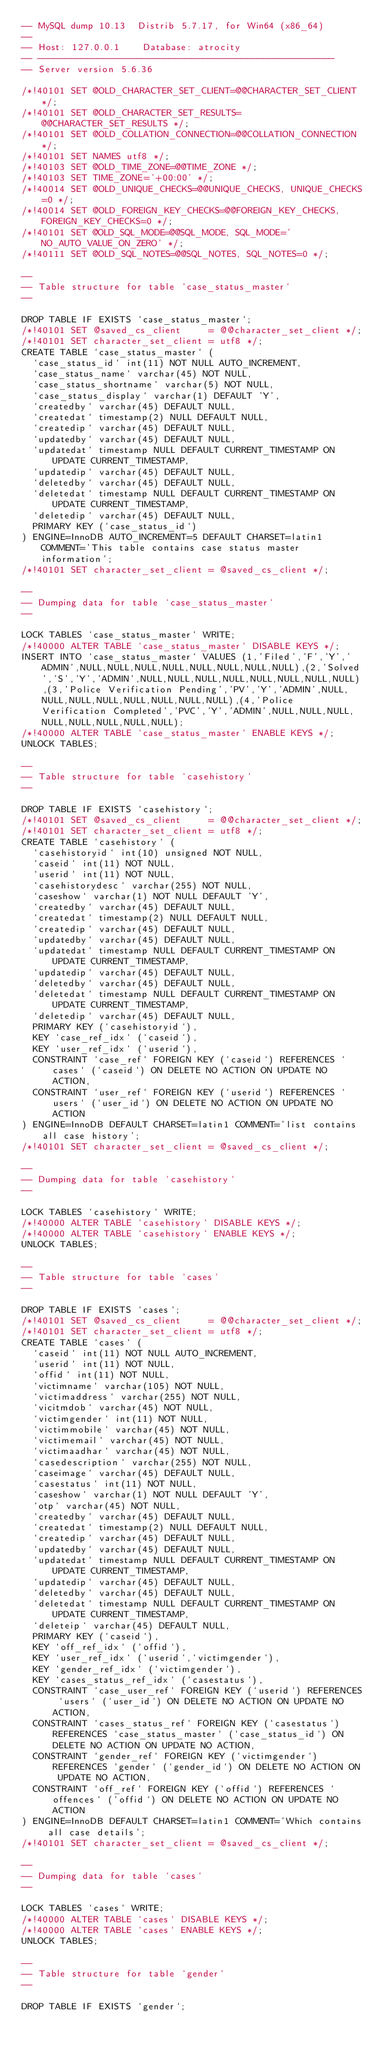Convert code to text. <code><loc_0><loc_0><loc_500><loc_500><_SQL_>-- MySQL dump 10.13  Distrib 5.7.17, for Win64 (x86_64)
--
-- Host: 127.0.0.1    Database: atrocity
-- ------------------------------------------------------
-- Server version	5.6.36

/*!40101 SET @OLD_CHARACTER_SET_CLIENT=@@CHARACTER_SET_CLIENT */;
/*!40101 SET @OLD_CHARACTER_SET_RESULTS=@@CHARACTER_SET_RESULTS */;
/*!40101 SET @OLD_COLLATION_CONNECTION=@@COLLATION_CONNECTION */;
/*!40101 SET NAMES utf8 */;
/*!40103 SET @OLD_TIME_ZONE=@@TIME_ZONE */;
/*!40103 SET TIME_ZONE='+00:00' */;
/*!40014 SET @OLD_UNIQUE_CHECKS=@@UNIQUE_CHECKS, UNIQUE_CHECKS=0 */;
/*!40014 SET @OLD_FOREIGN_KEY_CHECKS=@@FOREIGN_KEY_CHECKS, FOREIGN_KEY_CHECKS=0 */;
/*!40101 SET @OLD_SQL_MODE=@@SQL_MODE, SQL_MODE='NO_AUTO_VALUE_ON_ZERO' */;
/*!40111 SET @OLD_SQL_NOTES=@@SQL_NOTES, SQL_NOTES=0 */;

--
-- Table structure for table `case_status_master`
--

DROP TABLE IF EXISTS `case_status_master`;
/*!40101 SET @saved_cs_client     = @@character_set_client */;
/*!40101 SET character_set_client = utf8 */;
CREATE TABLE `case_status_master` (
  `case_status_id` int(11) NOT NULL AUTO_INCREMENT,
  `case_status_name` varchar(45) NOT NULL,
  `case_status_shortname` varchar(5) NOT NULL,
  `case_status_display` varchar(1) DEFAULT 'Y',
  `createdby` varchar(45) DEFAULT NULL,
  `createdat` timestamp(2) NULL DEFAULT NULL,
  `createdip` varchar(45) DEFAULT NULL,
  `updatedby` varchar(45) DEFAULT NULL,
  `updatedat` timestamp NULL DEFAULT CURRENT_TIMESTAMP ON UPDATE CURRENT_TIMESTAMP,
  `updatedip` varchar(45) DEFAULT NULL,
  `deletedby` varchar(45) DEFAULT NULL,
  `deletedat` timestamp NULL DEFAULT CURRENT_TIMESTAMP ON UPDATE CURRENT_TIMESTAMP,
  `deletedip` varchar(45) DEFAULT NULL,
  PRIMARY KEY (`case_status_id`)
) ENGINE=InnoDB AUTO_INCREMENT=5 DEFAULT CHARSET=latin1 COMMENT='This table contains case status master information';
/*!40101 SET character_set_client = @saved_cs_client */;

--
-- Dumping data for table `case_status_master`
--

LOCK TABLES `case_status_master` WRITE;
/*!40000 ALTER TABLE `case_status_master` DISABLE KEYS */;
INSERT INTO `case_status_master` VALUES (1,'Filed','F','Y','ADMIN',NULL,NULL,NULL,NULL,NULL,NULL,NULL,NULL),(2,'Solved','S','Y','ADMIN',NULL,NULL,NULL,NULL,NULL,NULL,NULL,NULL),(3,'Police Verification Pending','PV','Y','ADMIN',NULL,NULL,NULL,NULL,NULL,NULL,NULL,NULL),(4,'Police Verification Completed','PVC','Y','ADMIN',NULL,NULL,NULL,NULL,NULL,NULL,NULL,NULL);
/*!40000 ALTER TABLE `case_status_master` ENABLE KEYS */;
UNLOCK TABLES;

--
-- Table structure for table `casehistory`
--

DROP TABLE IF EXISTS `casehistory`;
/*!40101 SET @saved_cs_client     = @@character_set_client */;
/*!40101 SET character_set_client = utf8 */;
CREATE TABLE `casehistory` (
  `casehistoryid` int(10) unsigned NOT NULL,
  `caseid` int(11) NOT NULL,
  `userid` int(11) NOT NULL,
  `casehistorydesc` varchar(255) NOT NULL,
  `caseshow` varchar(1) NOT NULL DEFAULT 'Y',
  `createdby` varchar(45) DEFAULT NULL,
  `createdat` timestamp(2) NULL DEFAULT NULL,
  `createdip` varchar(45) DEFAULT NULL,
  `updatedby` varchar(45) DEFAULT NULL,
  `updatedat` timestamp NULL DEFAULT CURRENT_TIMESTAMP ON UPDATE CURRENT_TIMESTAMP,
  `updatedip` varchar(45) DEFAULT NULL,
  `deletedby` varchar(45) DEFAULT NULL,
  `deletedat` timestamp NULL DEFAULT CURRENT_TIMESTAMP ON UPDATE CURRENT_TIMESTAMP,
  `deletedip` varchar(45) DEFAULT NULL,
  PRIMARY KEY (`casehistoryid`),
  KEY `case_ref_idx` (`caseid`),
  KEY `user_ref_idx` (`userid`),
  CONSTRAINT `case_ref` FOREIGN KEY (`caseid`) REFERENCES `cases` (`caseid`) ON DELETE NO ACTION ON UPDATE NO ACTION,
  CONSTRAINT `user_ref` FOREIGN KEY (`userid`) REFERENCES `users` (`user_id`) ON DELETE NO ACTION ON UPDATE NO ACTION
) ENGINE=InnoDB DEFAULT CHARSET=latin1 COMMENT='list contains all case history';
/*!40101 SET character_set_client = @saved_cs_client */;

--
-- Dumping data for table `casehistory`
--

LOCK TABLES `casehistory` WRITE;
/*!40000 ALTER TABLE `casehistory` DISABLE KEYS */;
/*!40000 ALTER TABLE `casehistory` ENABLE KEYS */;
UNLOCK TABLES;

--
-- Table structure for table `cases`
--

DROP TABLE IF EXISTS `cases`;
/*!40101 SET @saved_cs_client     = @@character_set_client */;
/*!40101 SET character_set_client = utf8 */;
CREATE TABLE `cases` (
  `caseid` int(11) NOT NULL AUTO_INCREMENT,
  `userid` int(11) NOT NULL,
  `offid` int(11) NOT NULL,
  `victimname` varchar(105) NOT NULL,
  `victimaddress` varchar(255) NOT NULL,
  `vicitmdob` varchar(45) NOT NULL,
  `victimgender` int(11) NOT NULL,
  `victimmobile` varchar(45) NOT NULL,
  `victimemail` varchar(45) NOT NULL,
  `victimaadhar` varchar(45) NOT NULL,
  `casedescription` varchar(255) NOT NULL,
  `caseimage` varchar(45) DEFAULT NULL,
  `casestatus` int(11) NOT NULL,
  `caseshow` varchar(1) NOT NULL DEFAULT 'Y',
  `otp` varchar(45) NOT NULL,
  `createdby` varchar(45) DEFAULT NULL,
  `createdat` timestamp(2) NULL DEFAULT NULL,
  `createdip` varchar(45) DEFAULT NULL,
  `updatedby` varchar(45) DEFAULT NULL,
  `updatedat` timestamp NULL DEFAULT CURRENT_TIMESTAMP ON UPDATE CURRENT_TIMESTAMP,
  `updatedip` varchar(45) DEFAULT NULL,
  `deletedby` varchar(45) DEFAULT NULL,
  `deletedat` timestamp NULL DEFAULT CURRENT_TIMESTAMP ON UPDATE CURRENT_TIMESTAMP,
  `deleteip` varchar(45) DEFAULT NULL,
  PRIMARY KEY (`caseid`),
  KEY `off_ref_idx` (`offid`),
  KEY `user_ref_idx` (`userid`,`victimgender`),
  KEY `gender_ref_idx` (`victimgender`),
  KEY `cases_status_ref_idx` (`casestatus`),
  CONSTRAINT `case_user_ref` FOREIGN KEY (`userid`) REFERENCES `users` (`user_id`) ON DELETE NO ACTION ON UPDATE NO ACTION,
  CONSTRAINT `cases_status_ref` FOREIGN KEY (`casestatus`) REFERENCES `case_status_master` (`case_status_id`) ON DELETE NO ACTION ON UPDATE NO ACTION,
  CONSTRAINT `gender_ref` FOREIGN KEY (`victimgender`) REFERENCES `gender` (`gender_id`) ON DELETE NO ACTION ON UPDATE NO ACTION,
  CONSTRAINT `off_ref` FOREIGN KEY (`offid`) REFERENCES `offences` (`offid`) ON DELETE NO ACTION ON UPDATE NO ACTION
) ENGINE=InnoDB DEFAULT CHARSET=latin1 COMMENT='Which contains all case details';
/*!40101 SET character_set_client = @saved_cs_client */;

--
-- Dumping data for table `cases`
--

LOCK TABLES `cases` WRITE;
/*!40000 ALTER TABLE `cases` DISABLE KEYS */;
/*!40000 ALTER TABLE `cases` ENABLE KEYS */;
UNLOCK TABLES;

--
-- Table structure for table `gender`
--

DROP TABLE IF EXISTS `gender`;</code> 